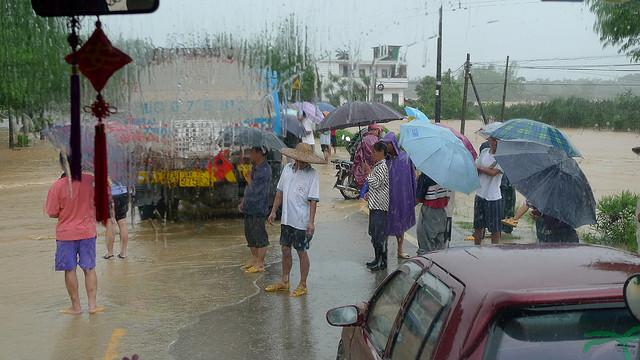What are the people holding the umbrellas trying to avoid? rain 